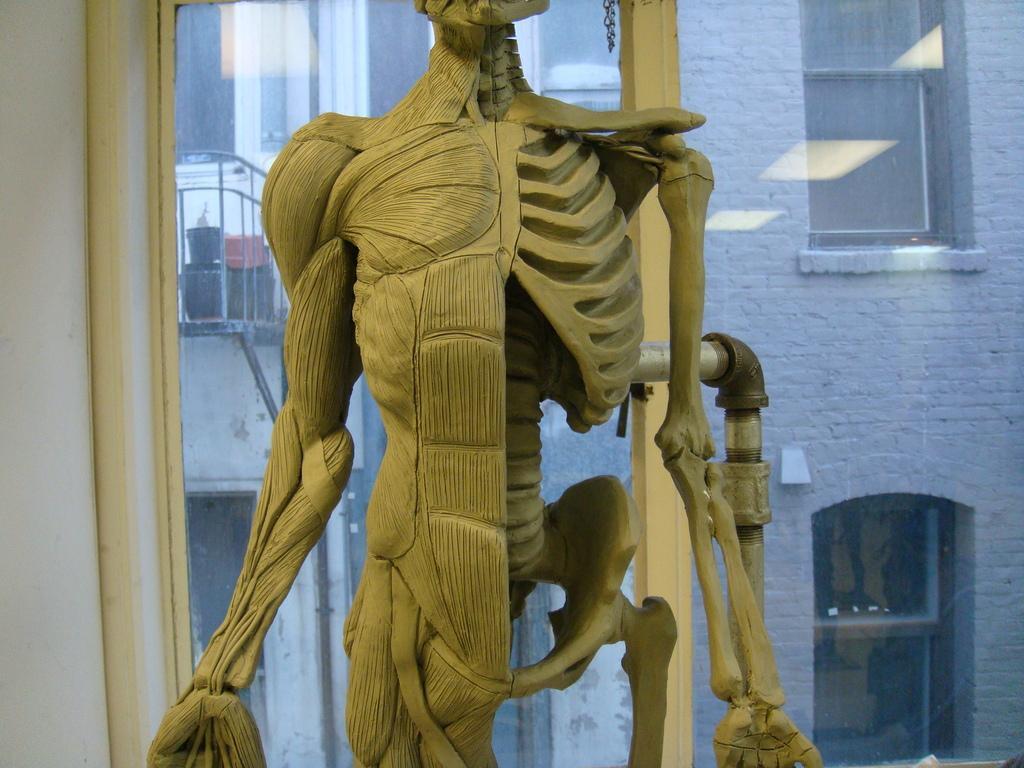In one or two sentences, can you explain what this image depicts? In this image we can see a skeleton, pipe, wall and window. Through the window glass we can see building, windows, railing and objects. 